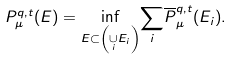<formula> <loc_0><loc_0><loc_500><loc_500>P _ { \mu } ^ { q , t } ( E ) = \underset { E \subset \left ( \underset { i } { \cup } E _ { i } \right ) } { \inf } \underset { i } { \sum } \overline { P } _ { \mu } ^ { q , t } ( E _ { i } ) .</formula> 